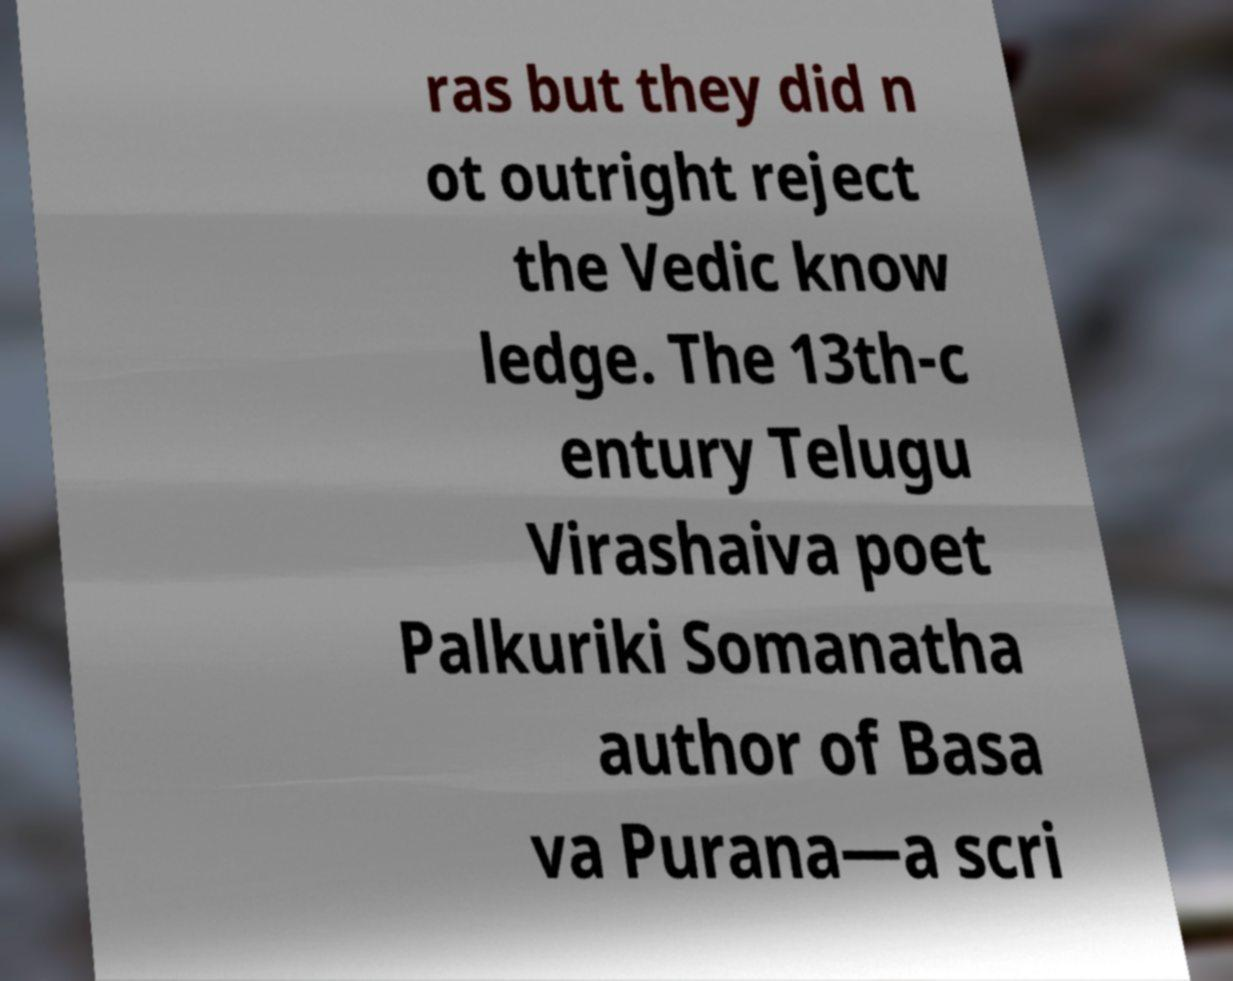For documentation purposes, I need the text within this image transcribed. Could you provide that? ras but they did n ot outright reject the Vedic know ledge. The 13th-c entury Telugu Virashaiva poet Palkuriki Somanatha author of Basa va Purana—a scri 